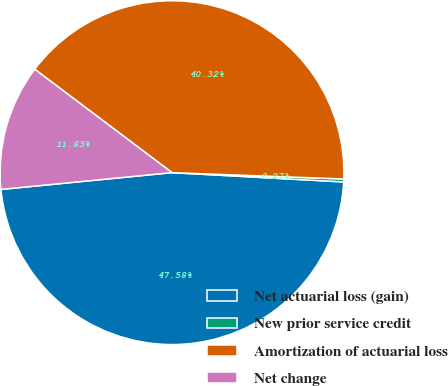Convert chart to OTSL. <chart><loc_0><loc_0><loc_500><loc_500><pie_chart><fcel>Net actuarial loss (gain)<fcel>New prior service credit<fcel>Amortization of actuarial loss<fcel>Net change<nl><fcel>47.58%<fcel>0.27%<fcel>40.32%<fcel>11.83%<nl></chart> 